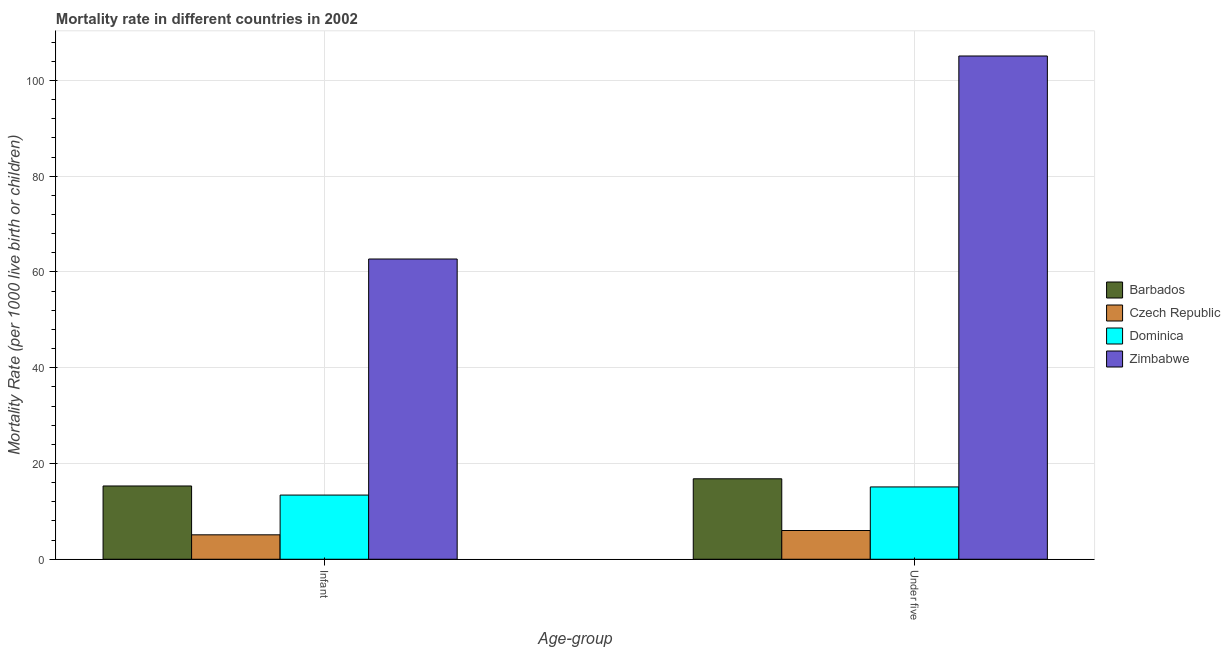Are the number of bars per tick equal to the number of legend labels?
Give a very brief answer. Yes. Are the number of bars on each tick of the X-axis equal?
Your answer should be very brief. Yes. How many bars are there on the 1st tick from the left?
Your response must be concise. 4. How many bars are there on the 2nd tick from the right?
Offer a very short reply. 4. What is the label of the 1st group of bars from the left?
Make the answer very short. Infant. What is the under-5 mortality rate in Czech Republic?
Make the answer very short. 6. Across all countries, what is the maximum infant mortality rate?
Your answer should be compact. 62.7. In which country was the infant mortality rate maximum?
Offer a terse response. Zimbabwe. In which country was the under-5 mortality rate minimum?
Keep it short and to the point. Czech Republic. What is the total under-5 mortality rate in the graph?
Your answer should be compact. 143. What is the difference between the infant mortality rate in Dominica and that in Zimbabwe?
Keep it short and to the point. -49.3. What is the difference between the infant mortality rate in Barbados and the under-5 mortality rate in Dominica?
Provide a succinct answer. 0.2. What is the average under-5 mortality rate per country?
Provide a succinct answer. 35.75. What is the difference between the infant mortality rate and under-5 mortality rate in Czech Republic?
Provide a short and direct response. -0.9. What is the ratio of the under-5 mortality rate in Zimbabwe to that in Barbados?
Your answer should be very brief. 6.26. In how many countries, is the under-5 mortality rate greater than the average under-5 mortality rate taken over all countries?
Provide a succinct answer. 1. What does the 3rd bar from the left in Infant represents?
Offer a very short reply. Dominica. What does the 2nd bar from the right in Infant represents?
Offer a very short reply. Dominica. Are all the bars in the graph horizontal?
Give a very brief answer. No. What is the difference between two consecutive major ticks on the Y-axis?
Ensure brevity in your answer.  20. Where does the legend appear in the graph?
Keep it short and to the point. Center right. How many legend labels are there?
Provide a succinct answer. 4. What is the title of the graph?
Make the answer very short. Mortality rate in different countries in 2002. What is the label or title of the X-axis?
Provide a succinct answer. Age-group. What is the label or title of the Y-axis?
Ensure brevity in your answer.  Mortality Rate (per 1000 live birth or children). What is the Mortality Rate (per 1000 live birth or children) of Barbados in Infant?
Keep it short and to the point. 15.3. What is the Mortality Rate (per 1000 live birth or children) in Czech Republic in Infant?
Your answer should be very brief. 5.1. What is the Mortality Rate (per 1000 live birth or children) of Dominica in Infant?
Keep it short and to the point. 13.4. What is the Mortality Rate (per 1000 live birth or children) in Zimbabwe in Infant?
Your answer should be very brief. 62.7. What is the Mortality Rate (per 1000 live birth or children) of Barbados in Under five?
Give a very brief answer. 16.8. What is the Mortality Rate (per 1000 live birth or children) in Czech Republic in Under five?
Offer a terse response. 6. What is the Mortality Rate (per 1000 live birth or children) in Dominica in Under five?
Offer a terse response. 15.1. What is the Mortality Rate (per 1000 live birth or children) in Zimbabwe in Under five?
Your response must be concise. 105.1. Across all Age-group, what is the maximum Mortality Rate (per 1000 live birth or children) in Zimbabwe?
Your answer should be compact. 105.1. Across all Age-group, what is the minimum Mortality Rate (per 1000 live birth or children) in Czech Republic?
Ensure brevity in your answer.  5.1. Across all Age-group, what is the minimum Mortality Rate (per 1000 live birth or children) of Zimbabwe?
Give a very brief answer. 62.7. What is the total Mortality Rate (per 1000 live birth or children) of Barbados in the graph?
Keep it short and to the point. 32.1. What is the total Mortality Rate (per 1000 live birth or children) of Czech Republic in the graph?
Make the answer very short. 11.1. What is the total Mortality Rate (per 1000 live birth or children) of Dominica in the graph?
Your response must be concise. 28.5. What is the total Mortality Rate (per 1000 live birth or children) in Zimbabwe in the graph?
Offer a very short reply. 167.8. What is the difference between the Mortality Rate (per 1000 live birth or children) in Dominica in Infant and that in Under five?
Your response must be concise. -1.7. What is the difference between the Mortality Rate (per 1000 live birth or children) of Zimbabwe in Infant and that in Under five?
Offer a very short reply. -42.4. What is the difference between the Mortality Rate (per 1000 live birth or children) in Barbados in Infant and the Mortality Rate (per 1000 live birth or children) in Dominica in Under five?
Provide a short and direct response. 0.2. What is the difference between the Mortality Rate (per 1000 live birth or children) in Barbados in Infant and the Mortality Rate (per 1000 live birth or children) in Zimbabwe in Under five?
Give a very brief answer. -89.8. What is the difference between the Mortality Rate (per 1000 live birth or children) of Czech Republic in Infant and the Mortality Rate (per 1000 live birth or children) of Zimbabwe in Under five?
Ensure brevity in your answer.  -100. What is the difference between the Mortality Rate (per 1000 live birth or children) in Dominica in Infant and the Mortality Rate (per 1000 live birth or children) in Zimbabwe in Under five?
Offer a very short reply. -91.7. What is the average Mortality Rate (per 1000 live birth or children) in Barbados per Age-group?
Ensure brevity in your answer.  16.05. What is the average Mortality Rate (per 1000 live birth or children) of Czech Republic per Age-group?
Provide a succinct answer. 5.55. What is the average Mortality Rate (per 1000 live birth or children) of Dominica per Age-group?
Give a very brief answer. 14.25. What is the average Mortality Rate (per 1000 live birth or children) in Zimbabwe per Age-group?
Make the answer very short. 83.9. What is the difference between the Mortality Rate (per 1000 live birth or children) in Barbados and Mortality Rate (per 1000 live birth or children) in Zimbabwe in Infant?
Offer a terse response. -47.4. What is the difference between the Mortality Rate (per 1000 live birth or children) of Czech Republic and Mortality Rate (per 1000 live birth or children) of Zimbabwe in Infant?
Keep it short and to the point. -57.6. What is the difference between the Mortality Rate (per 1000 live birth or children) of Dominica and Mortality Rate (per 1000 live birth or children) of Zimbabwe in Infant?
Keep it short and to the point. -49.3. What is the difference between the Mortality Rate (per 1000 live birth or children) in Barbados and Mortality Rate (per 1000 live birth or children) in Dominica in Under five?
Offer a terse response. 1.7. What is the difference between the Mortality Rate (per 1000 live birth or children) in Barbados and Mortality Rate (per 1000 live birth or children) in Zimbabwe in Under five?
Keep it short and to the point. -88.3. What is the difference between the Mortality Rate (per 1000 live birth or children) of Czech Republic and Mortality Rate (per 1000 live birth or children) of Dominica in Under five?
Make the answer very short. -9.1. What is the difference between the Mortality Rate (per 1000 live birth or children) of Czech Republic and Mortality Rate (per 1000 live birth or children) of Zimbabwe in Under five?
Keep it short and to the point. -99.1. What is the difference between the Mortality Rate (per 1000 live birth or children) of Dominica and Mortality Rate (per 1000 live birth or children) of Zimbabwe in Under five?
Keep it short and to the point. -90. What is the ratio of the Mortality Rate (per 1000 live birth or children) in Barbados in Infant to that in Under five?
Your response must be concise. 0.91. What is the ratio of the Mortality Rate (per 1000 live birth or children) in Czech Republic in Infant to that in Under five?
Make the answer very short. 0.85. What is the ratio of the Mortality Rate (per 1000 live birth or children) in Dominica in Infant to that in Under five?
Offer a terse response. 0.89. What is the ratio of the Mortality Rate (per 1000 live birth or children) of Zimbabwe in Infant to that in Under five?
Offer a terse response. 0.6. What is the difference between the highest and the second highest Mortality Rate (per 1000 live birth or children) of Barbados?
Provide a short and direct response. 1.5. What is the difference between the highest and the second highest Mortality Rate (per 1000 live birth or children) in Dominica?
Offer a terse response. 1.7. What is the difference between the highest and the second highest Mortality Rate (per 1000 live birth or children) in Zimbabwe?
Provide a succinct answer. 42.4. What is the difference between the highest and the lowest Mortality Rate (per 1000 live birth or children) of Barbados?
Give a very brief answer. 1.5. What is the difference between the highest and the lowest Mortality Rate (per 1000 live birth or children) in Czech Republic?
Offer a terse response. 0.9. What is the difference between the highest and the lowest Mortality Rate (per 1000 live birth or children) in Zimbabwe?
Your response must be concise. 42.4. 